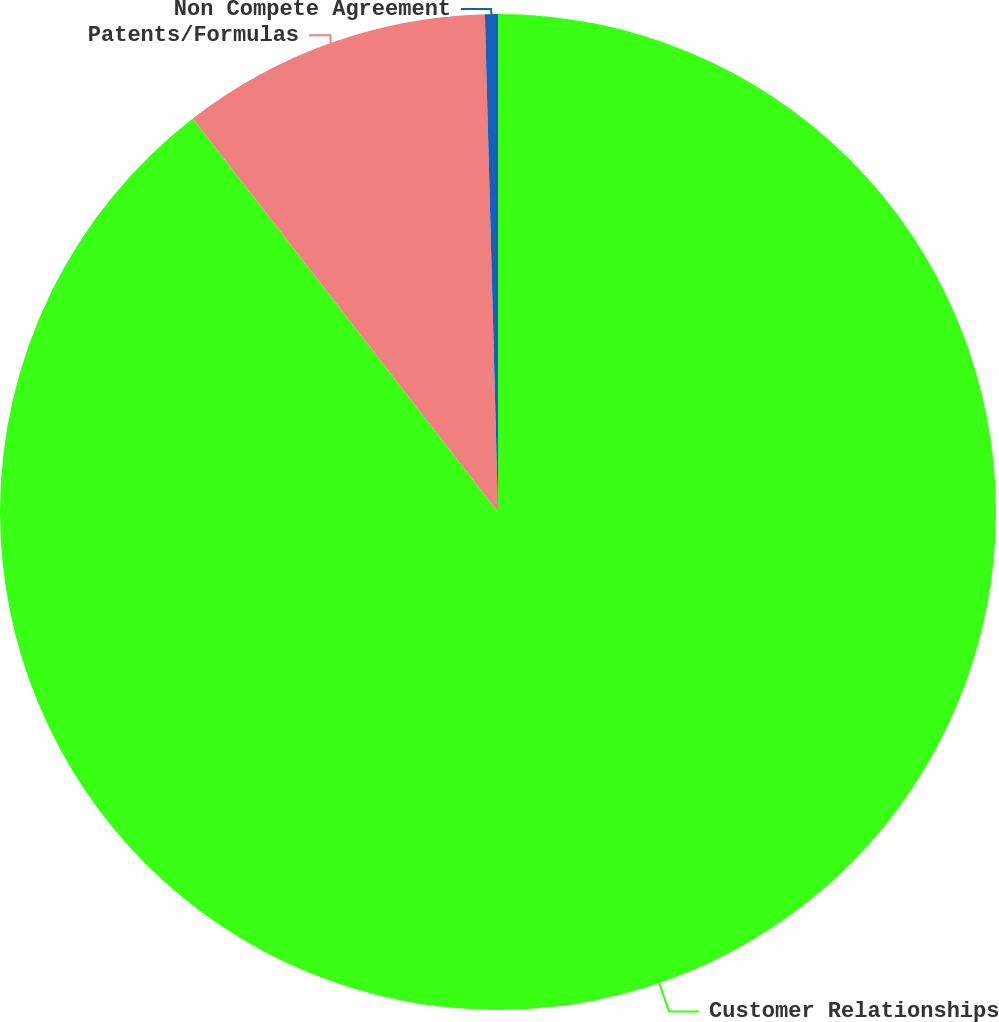<chart> <loc_0><loc_0><loc_500><loc_500><pie_chart><fcel>Customer Relationships<fcel>Patents/Formulas<fcel>Non Compete Agreement<nl><fcel>89.5%<fcel>10.08%<fcel>0.42%<nl></chart> 